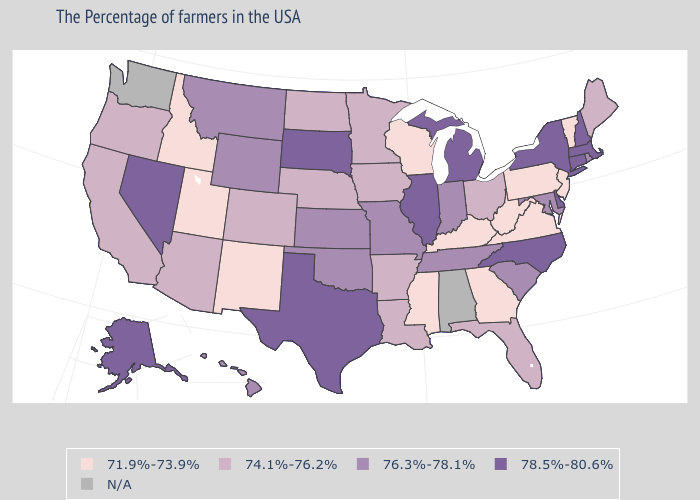Does Nevada have the highest value in the USA?
Write a very short answer. Yes. Does the first symbol in the legend represent the smallest category?
Short answer required. Yes. Does South Dakota have the highest value in the USA?
Write a very short answer. Yes. Which states hav the highest value in the South?
Concise answer only. Delaware, North Carolina, Texas. Name the states that have a value in the range 78.5%-80.6%?
Give a very brief answer. Massachusetts, New Hampshire, Connecticut, New York, Delaware, North Carolina, Michigan, Illinois, Texas, South Dakota, Nevada, Alaska. Name the states that have a value in the range 78.5%-80.6%?
Keep it brief. Massachusetts, New Hampshire, Connecticut, New York, Delaware, North Carolina, Michigan, Illinois, Texas, South Dakota, Nevada, Alaska. Does the first symbol in the legend represent the smallest category?
Give a very brief answer. Yes. Name the states that have a value in the range 78.5%-80.6%?
Be succinct. Massachusetts, New Hampshire, Connecticut, New York, Delaware, North Carolina, Michigan, Illinois, Texas, South Dakota, Nevada, Alaska. Does Maine have the highest value in the Northeast?
Give a very brief answer. No. Does New York have the lowest value in the Northeast?
Give a very brief answer. No. Which states have the lowest value in the USA?
Answer briefly. Vermont, New Jersey, Pennsylvania, Virginia, West Virginia, Georgia, Kentucky, Wisconsin, Mississippi, New Mexico, Utah, Idaho. Among the states that border Michigan , which have the lowest value?
Quick response, please. Wisconsin. Is the legend a continuous bar?
Short answer required. No. How many symbols are there in the legend?
Be succinct. 5. What is the highest value in the South ?
Keep it brief. 78.5%-80.6%. 